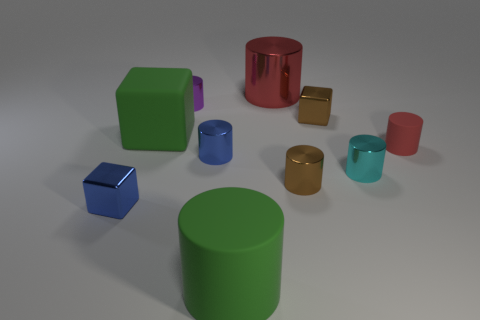Subtract all cyan shiny cylinders. How many cylinders are left? 6 Subtract all brown cylinders. How many cylinders are left? 6 Subtract all yellow cylinders. Subtract all red spheres. How many cylinders are left? 7 Subtract all cylinders. How many objects are left? 3 Add 4 large metal cylinders. How many large metal cylinders are left? 5 Add 4 small purple metallic cylinders. How many small purple metallic cylinders exist? 5 Subtract 0 gray cylinders. How many objects are left? 10 Subtract all tiny purple cubes. Subtract all large metallic things. How many objects are left? 9 